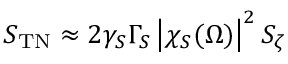<formula> <loc_0><loc_0><loc_500><loc_500>S _ { T N } \approx 2 \gamma _ { S } \Gamma _ { S } \left | \chi _ { S } ( \Omega ) \right | ^ { 2 } S _ { \zeta }</formula> 